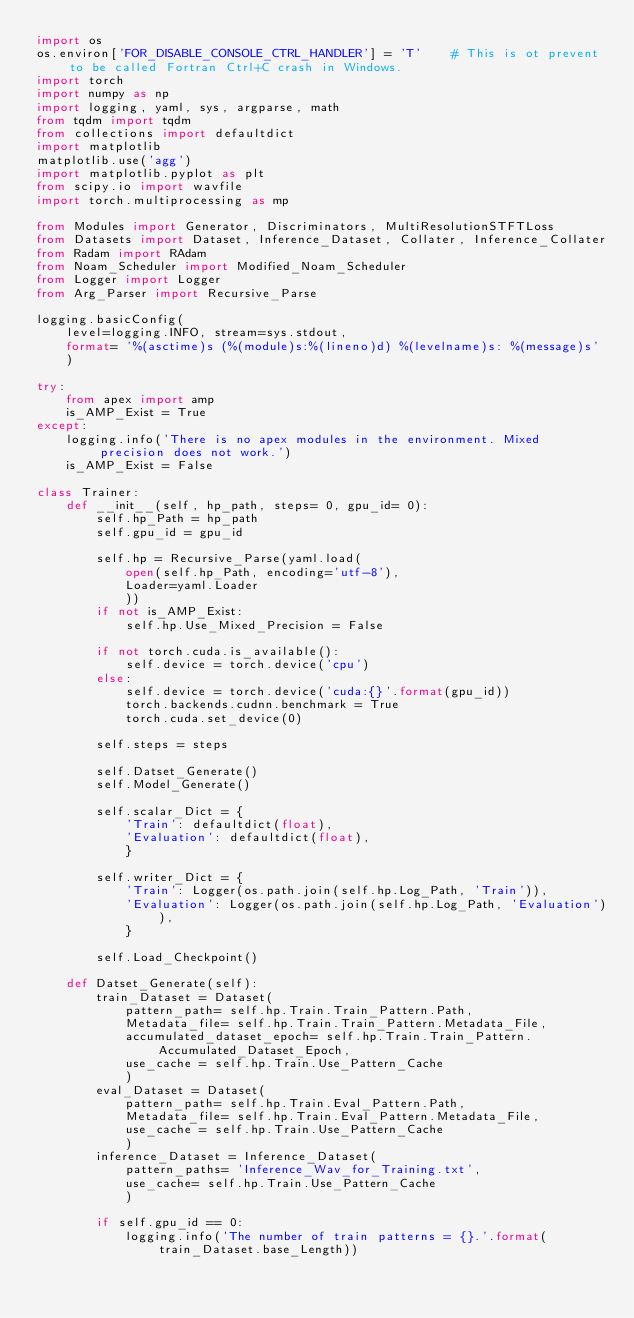Convert code to text. <code><loc_0><loc_0><loc_500><loc_500><_Python_>import os
os.environ['FOR_DISABLE_CONSOLE_CTRL_HANDLER'] = 'T'    # This is ot prevent to be called Fortran Ctrl+C crash in Windows.
import torch
import numpy as np
import logging, yaml, sys, argparse, math
from tqdm import tqdm
from collections import defaultdict
import matplotlib
matplotlib.use('agg')
import matplotlib.pyplot as plt
from scipy.io import wavfile
import torch.multiprocessing as mp

from Modules import Generator, Discriminators, MultiResolutionSTFTLoss
from Datasets import Dataset, Inference_Dataset, Collater, Inference_Collater
from Radam import RAdam
from Noam_Scheduler import Modified_Noam_Scheduler
from Logger import Logger
from Arg_Parser import Recursive_Parse

logging.basicConfig(
    level=logging.INFO, stream=sys.stdout,
    format= '%(asctime)s (%(module)s:%(lineno)d) %(levelname)s: %(message)s'
    )

try:
    from apex import amp
    is_AMP_Exist = True
except:
    logging.info('There is no apex modules in the environment. Mixed precision does not work.')
    is_AMP_Exist = False

class Trainer:
    def __init__(self, hp_path, steps= 0, gpu_id= 0):
        self.hp_Path = hp_path
        self.gpu_id = gpu_id
        
        self.hp = Recursive_Parse(yaml.load(
            open(self.hp_Path, encoding='utf-8'),
            Loader=yaml.Loader
            ))
        if not is_AMP_Exist:
            self.hp.Use_Mixed_Precision = False

        if not torch.cuda.is_available():
            self.device = torch.device('cpu')
        else:
            self.device = torch.device('cuda:{}'.format(gpu_id))
            torch.backends.cudnn.benchmark = True
            torch.cuda.set_device(0)

        self.steps = steps

        self.Datset_Generate()
        self.Model_Generate()

        self.scalar_Dict = {
            'Train': defaultdict(float),
            'Evaluation': defaultdict(float),
            }

        self.writer_Dict = {
            'Train': Logger(os.path.join(self.hp.Log_Path, 'Train')),
            'Evaluation': Logger(os.path.join(self.hp.Log_Path, 'Evaluation')),
            }
        
        self.Load_Checkpoint()

    def Datset_Generate(self):
        train_Dataset = Dataset(
            pattern_path= self.hp.Train.Train_Pattern.Path,
            Metadata_file= self.hp.Train.Train_Pattern.Metadata_File,
            accumulated_dataset_epoch= self.hp.Train.Train_Pattern.Accumulated_Dataset_Epoch,
            use_cache = self.hp.Train.Use_Pattern_Cache
            )
        eval_Dataset = Dataset(
            pattern_path= self.hp.Train.Eval_Pattern.Path,
            Metadata_file= self.hp.Train.Eval_Pattern.Metadata_File,
            use_cache = self.hp.Train.Use_Pattern_Cache
            )
        inference_Dataset = Inference_Dataset(
            pattern_paths= 'Inference_Wav_for_Training.txt',
            use_cache= self.hp.Train.Use_Pattern_Cache
            )

        if self.gpu_id == 0:
            logging.info('The number of train patterns = {}.'.format(train_Dataset.base_Length))</code> 